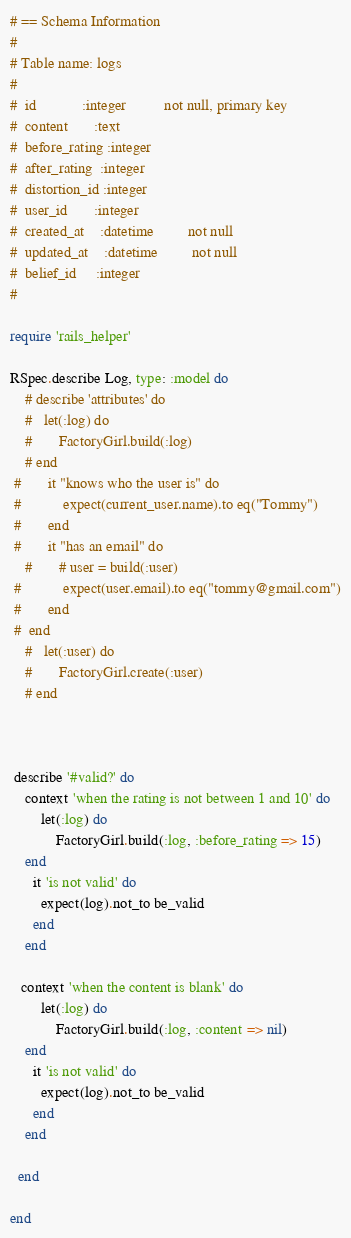<code> <loc_0><loc_0><loc_500><loc_500><_Ruby_># == Schema Information
#
# Table name: logs
#
#  id            :integer          not null, primary key
#  content       :text
#  before_rating :integer
#  after_rating  :integer
#  distortion_id :integer
#  user_id       :integer
#  created_at    :datetime         not null
#  updated_at    :datetime         not null
#  belief_id     :integer
#

require 'rails_helper'

RSpec.describe Log, type: :model do
	# describe 'attributes' do
	# 	let(:log) do
	# 		FactoryGirl.build(:log)
	# end
 #  		it "knows who the user is" do
 #  			expect(current_user.name).to eq("Tommy")
 #  		end
 #  		it "has an email" do
	# 		# user = build(:user) 		  			  			
 #  			expect(user.email).to eq("tommy@gmail.com")
 #  		end  	
 #  end
	# 	let(:user) do
	# 		FactoryGirl.create(:user)
	# end



 describe '#valid?' do
    context 'when the rating is not between 1 and 10' do
		let(:log) do
			FactoryGirl.build(:log, :before_rating => 15)
	end    	
      it 'is not valid' do 
        expect(log).not_to be_valid
      end
    end
 
   context 'when the content is blank' do
		let(:log) do
			FactoryGirl.build(:log, :content => nil)
	end    	
      it 'is not valid' do 
        expect(log).not_to be_valid
      end
    end

  end

end</code> 